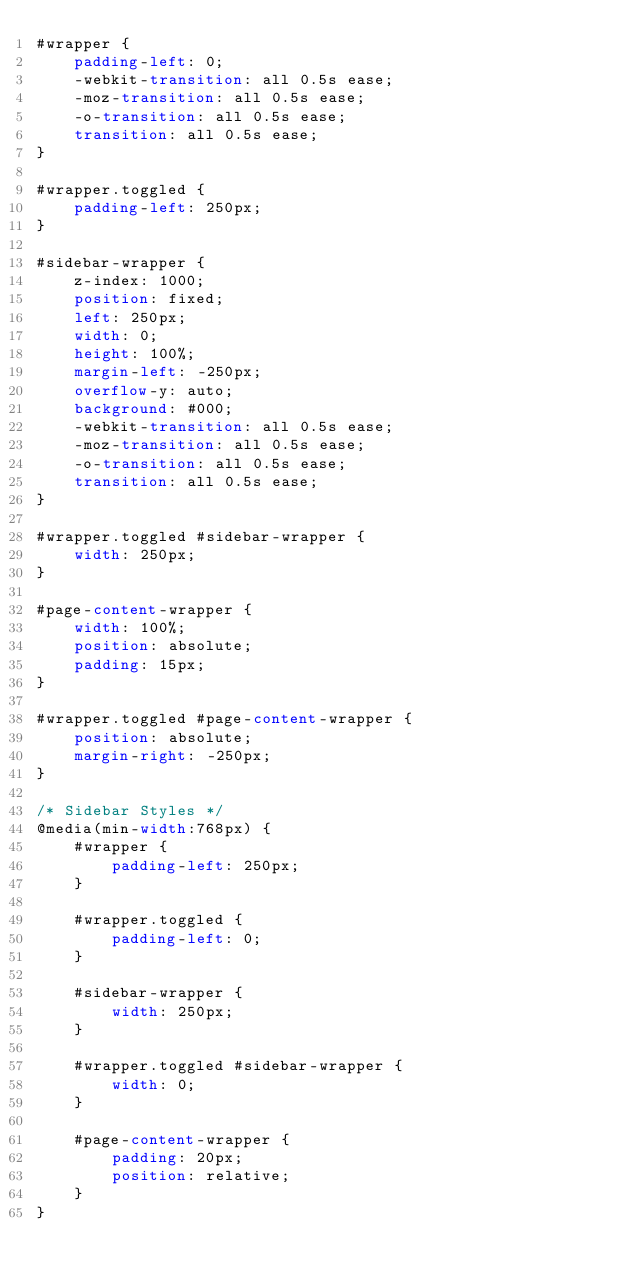Convert code to text. <code><loc_0><loc_0><loc_500><loc_500><_CSS_>#wrapper {
    padding-left: 0;
    -webkit-transition: all 0.5s ease;
    -moz-transition: all 0.5s ease;
    -o-transition: all 0.5s ease;
    transition: all 0.5s ease;
}

#wrapper.toggled {
    padding-left: 250px;
}

#sidebar-wrapper {
    z-index: 1000;
    position: fixed;
    left: 250px;
    width: 0;
    height: 100%;
    margin-left: -250px;
    overflow-y: auto;
    background: #000;
    -webkit-transition: all 0.5s ease;
    -moz-transition: all 0.5s ease;
    -o-transition: all 0.5s ease;
    transition: all 0.5s ease;
}

#wrapper.toggled #sidebar-wrapper {
    width: 250px;
}

#page-content-wrapper {
    width: 100%;
    position: absolute;
    padding: 15px;
}

#wrapper.toggled #page-content-wrapper {
    position: absolute;
    margin-right: -250px;
}

/* Sidebar Styles */
@media(min-width:768px) {
    #wrapper {
        padding-left: 250px;
    }

    #wrapper.toggled {
        padding-left: 0;
    }

    #sidebar-wrapper {
        width: 250px;
    }

    #wrapper.toggled #sidebar-wrapper {
        width: 0;
    }

    #page-content-wrapper {
        padding: 20px;
        position: relative;
    }
}
</code> 